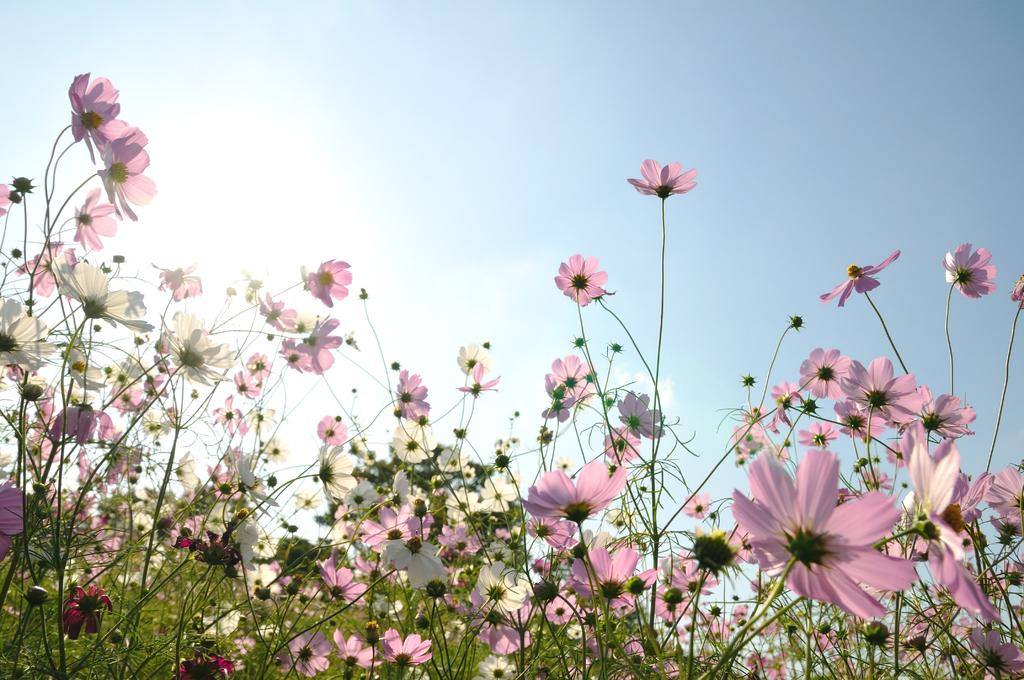What type of plants are present in the image? There are plants with flowers in the image. What stage of growth are the flowers on the plants? The plants have both flowers and buds in the image. What is visible at the top of the image? The sky is visible at the top of the image. What can be seen in the sky? There are clouds in the sky. What colors are the flowers on the plants? The flowers are in pink, white, and red colors. Where is the woman being held in jail in the image? There is no woman or jail present in the image; it features plants with flowers and a sky with clouds. 